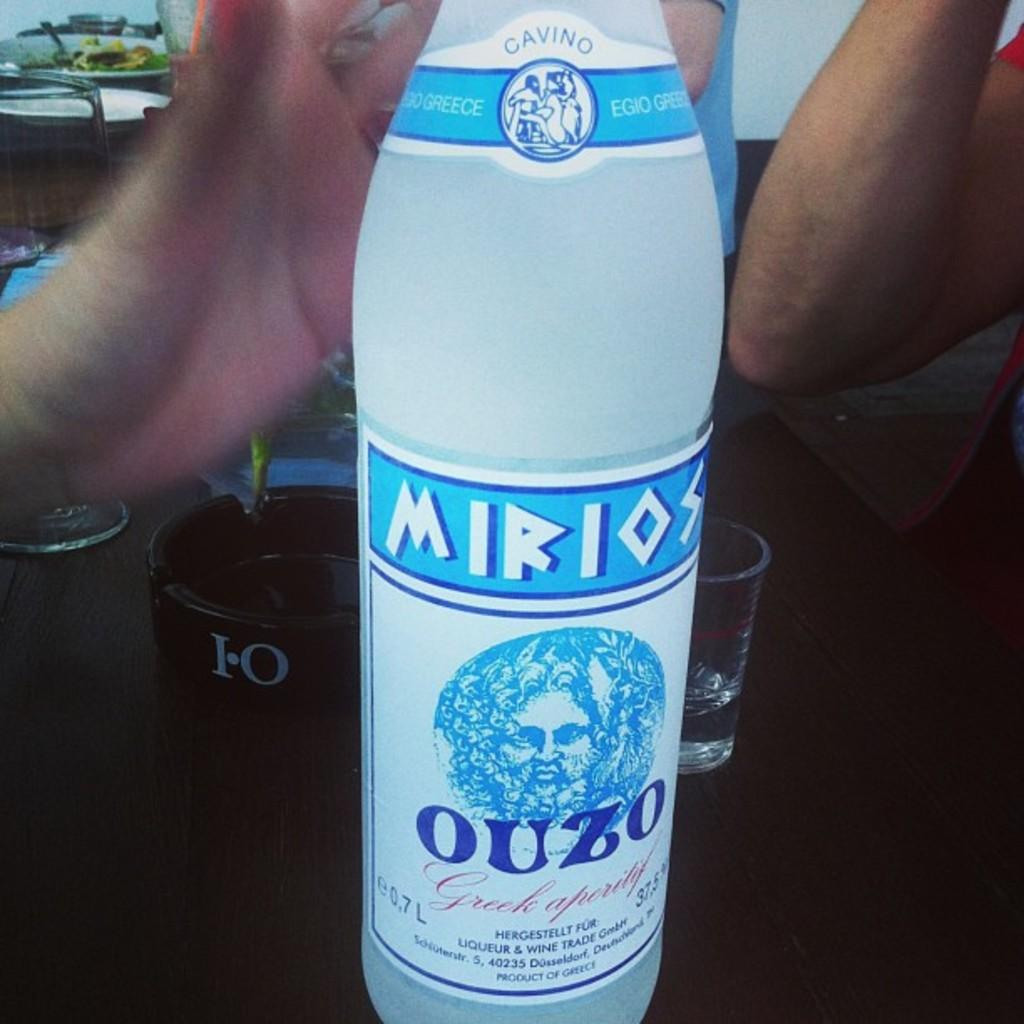What object is placed on the table in the image? There is a bottle on the table in the image. What is located behind the bottle? There is a glass behind the bottle. What is placed behind the glass? There is an ash tray behind the glass. Can you describe the person in the image? There is a person sitting in the right corner of the image. What page of the calendar is visible in the image? There is no calendar present in the image. What causes the object to burst in the image? There is no object bursting in the image. 